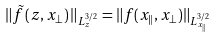Convert formula to latex. <formula><loc_0><loc_0><loc_500><loc_500>\| \tilde { f } \left ( z , x _ { \perp } \right ) \| _ { L ^ { 3 / 2 } _ { z } } = \| f ( x _ { \| } , x _ { \perp } ) \| _ { L ^ { 3 / 2 } _ { x _ { \| } } }</formula> 